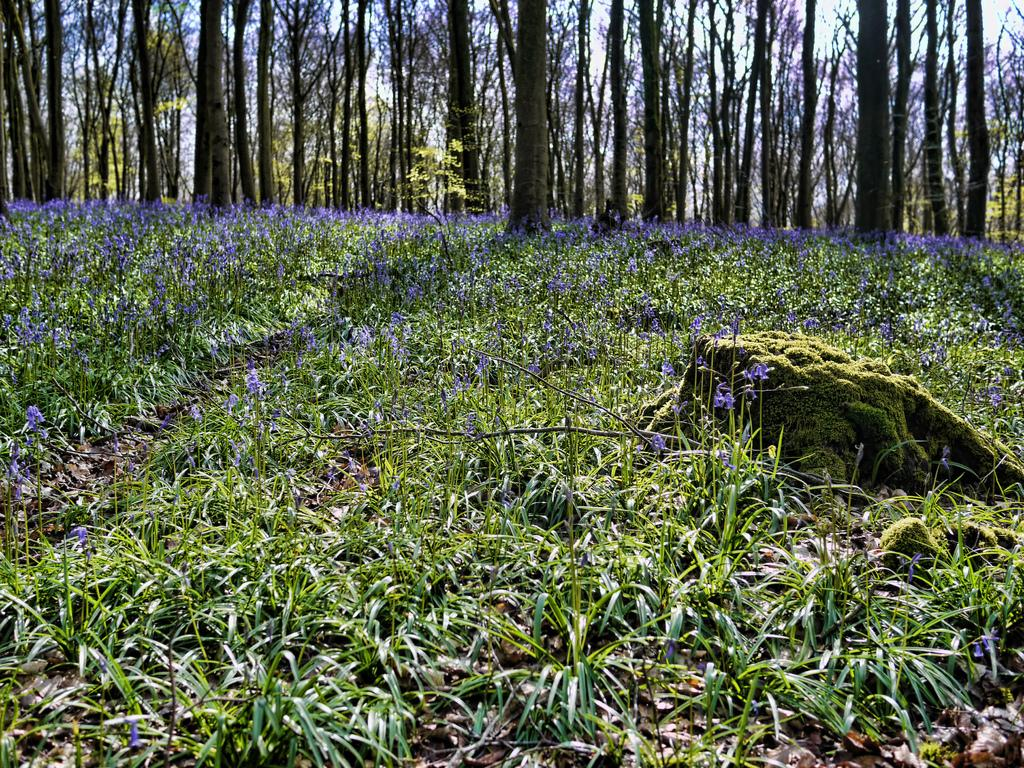What type of flowers can be seen in the image? There are violet color flowers in the image. Where are the flowers located? The flowers are on plants. What can be seen in the background of the image? There are trees and the sky visible in the background of the image. What type of gun is present in the image? There is no gun present in the image; it features violet color flowers on plants with trees and the sky visible in the background. 